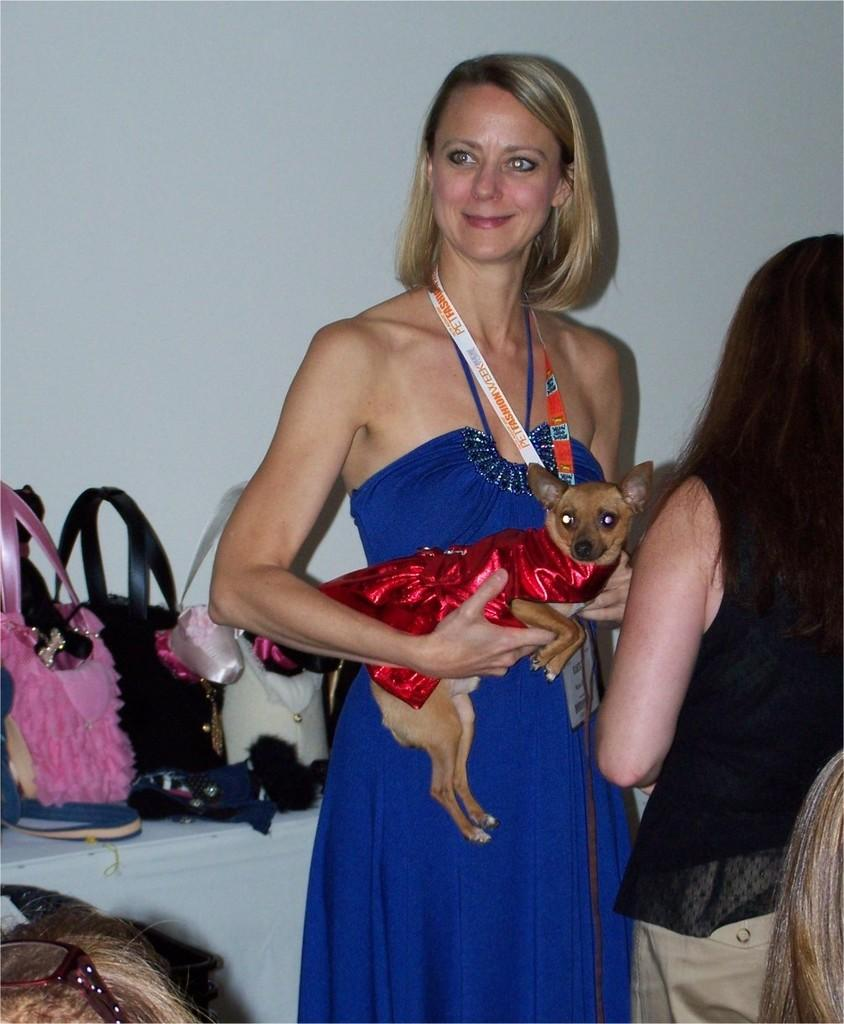Who is the main subject in the image? There is a lady in the center of the image. What is the lady holding in her hand? The lady is holding a cat in her hand. What can be seen on the desk behind the lady? There are bags on the desk behind the lady. What type of punishment is the lady receiving in the image? There is no indication of punishment in the image; the lady is holding a cat. What kind of test is the lady taking in the image? There is no test present in the image; the lady is holding a cat. 